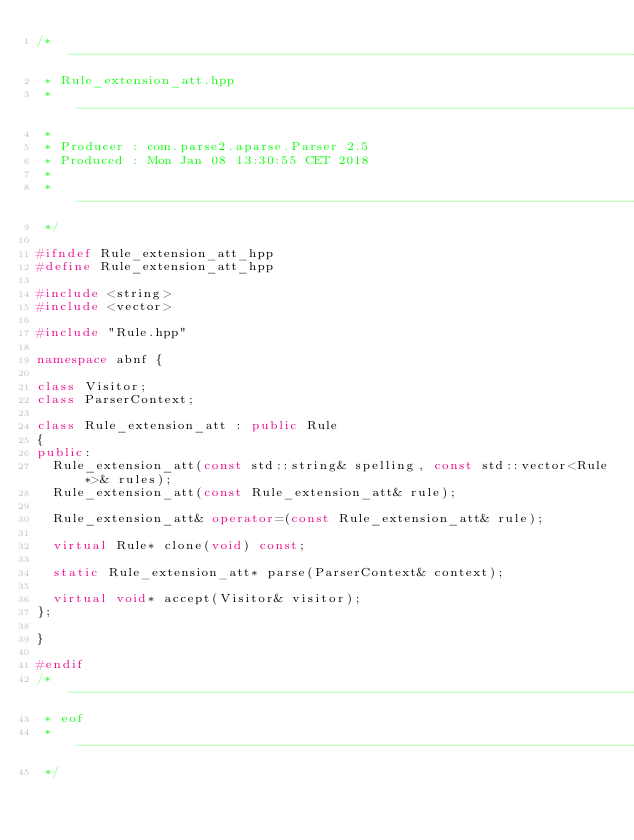<code> <loc_0><loc_0><loc_500><loc_500><_C++_>/* -----------------------------------------------------------------------------
 * Rule_extension_att.hpp
 * -----------------------------------------------------------------------------
 *
 * Producer : com.parse2.aparse.Parser 2.5
 * Produced : Mon Jan 08 13:30:55 CET 2018
 *
 * -----------------------------------------------------------------------------
 */

#ifndef Rule_extension_att_hpp
#define Rule_extension_att_hpp

#include <string>
#include <vector>

#include "Rule.hpp"

namespace abnf {

class Visitor;
class ParserContext;

class Rule_extension_att : public Rule
{
public:
  Rule_extension_att(const std::string& spelling, const std::vector<Rule*>& rules);
  Rule_extension_att(const Rule_extension_att& rule);

  Rule_extension_att& operator=(const Rule_extension_att& rule);

  virtual Rule* clone(void) const;

  static Rule_extension_att* parse(ParserContext& context);

  virtual void* accept(Visitor& visitor);
};

}

#endif
/* -----------------------------------------------------------------------------
 * eof
 * -----------------------------------------------------------------------------
 */
</code> 